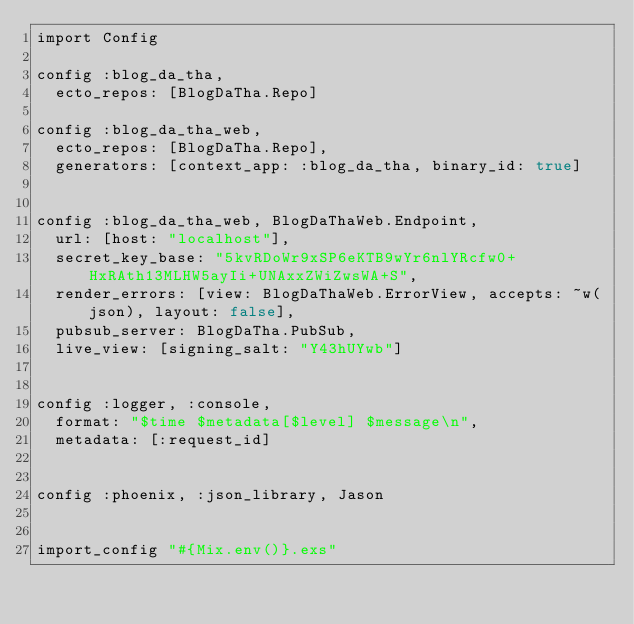<code> <loc_0><loc_0><loc_500><loc_500><_Elixir_>import Config

config :blog_da_tha,
  ecto_repos: [BlogDaTha.Repo]

config :blog_da_tha_web,
  ecto_repos: [BlogDaTha.Repo],
  generators: [context_app: :blog_da_tha, binary_id: true]


config :blog_da_tha_web, BlogDaThaWeb.Endpoint,
  url: [host: "localhost"],
  secret_key_base: "5kvRDoWr9xSP6eKTB9wYr6nlYRcfw0+HxRAth13MLHW5ayIi+UNAxxZWiZwsWA+S",
  render_errors: [view: BlogDaThaWeb.ErrorView, accepts: ~w(json), layout: false],
  pubsub_server: BlogDaTha.PubSub,
  live_view: [signing_salt: "Y43hUYwb"]


config :logger, :console,
  format: "$time $metadata[$level] $message\n",
  metadata: [:request_id]


config :phoenix, :json_library, Jason


import_config "#{Mix.env()}.exs"
</code> 